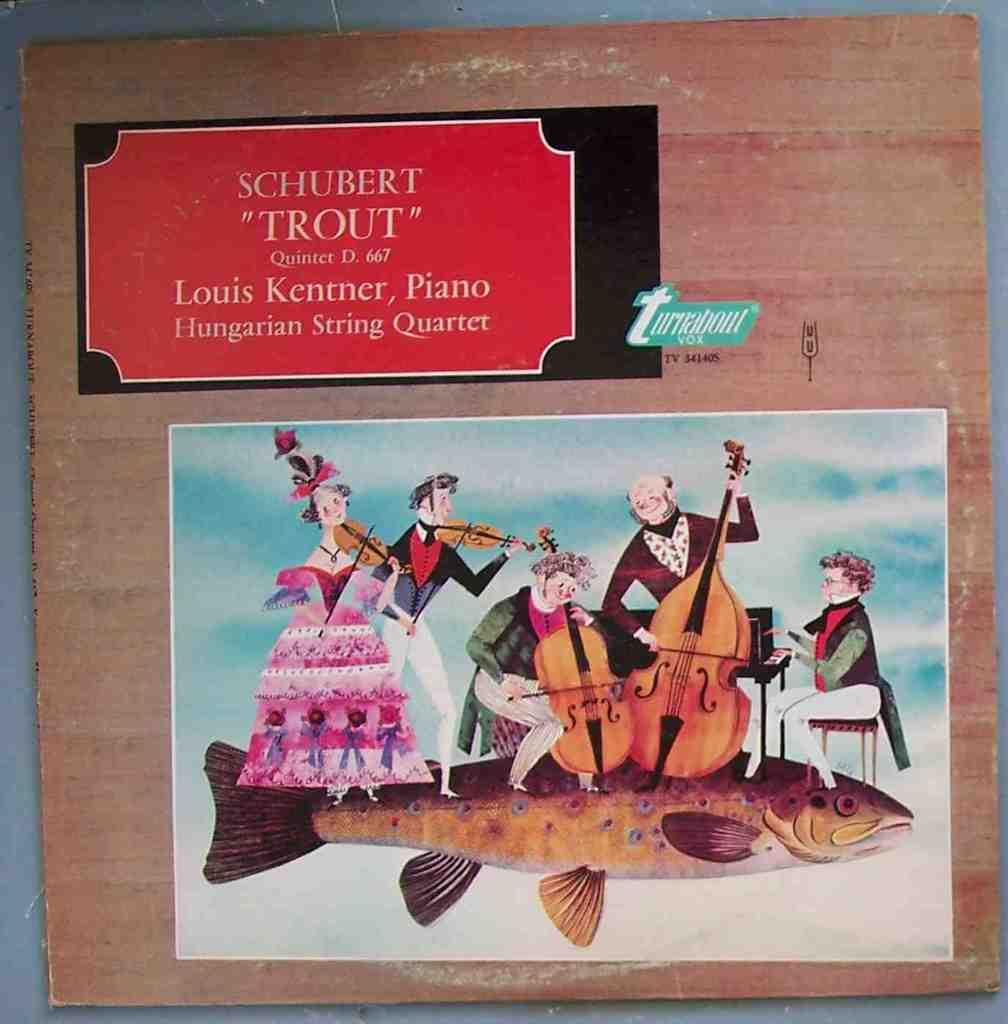What is depicted at the bottom of the scene? There is an image at the bottom of the scene. What type of animals are in the image? There are fish in the image. What are people doing in the image? People are standing on the fish, sitting on the fish, and playing musical instruments on the fish. What type of war is being depicted in the image? There is no war depicted in the image; it features people interacting with fish. Can you see an owl in the image? There is no owl present in the image; it features fish and people. 